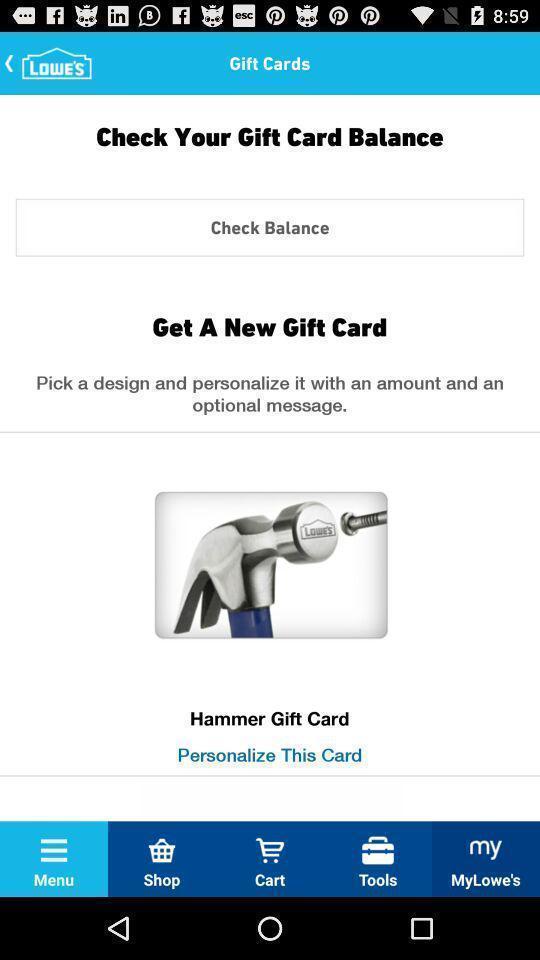Summarize the main components in this picture. Screen showing about gift cards. 